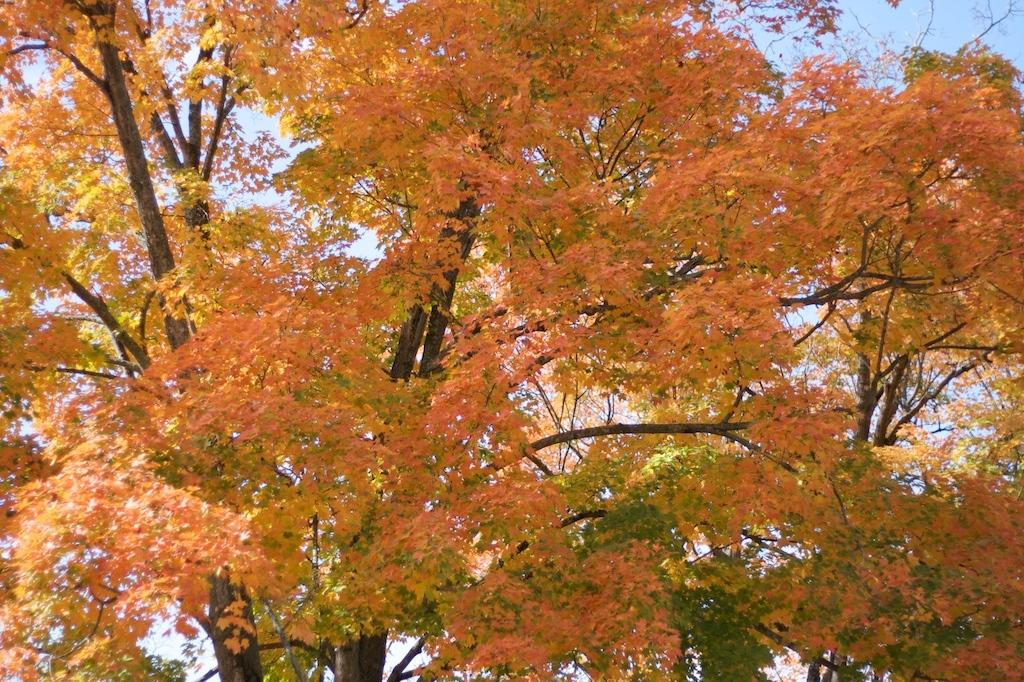What type of vegetation can be seen in the image? There are trees in the image. What colors are present on the trees in the image? The trees have green, yellow, and orange colors. What else is visible in the image besides the trees? The sky is visible in the image. What type of creature is wearing a mitten in the image? There is no creature wearing a mitten present in the image. What is the weight of the trees in the image? The weight of the trees cannot be determined from the image, as it is not possible to weigh them based on a photograph. 